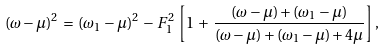Convert formula to latex. <formula><loc_0><loc_0><loc_500><loc_500>( \omega - \mu ) ^ { 2 } \, = \, ( \omega _ { 1 } - \mu ) ^ { 2 } \, - \, F _ { 1 } ^ { 2 } \, \left [ 1 \, + \, \frac { ( \omega - \mu ) + ( \omega _ { 1 } - \mu ) } { ( \omega - \mu ) + ( \omega _ { 1 } - \mu ) + 4 \mu } \right ] ,</formula> 